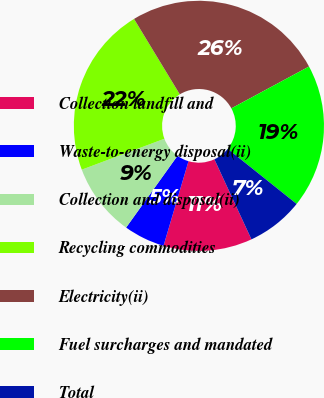<chart> <loc_0><loc_0><loc_500><loc_500><pie_chart><fcel>Collection landfill and<fcel>Waste-to-energy disposal(ii)<fcel>Collection and disposal(ii)<fcel>Recycling commodities<fcel>Electricity(ii)<fcel>Fuel surcharges and mandated<fcel>Total<nl><fcel>11.47%<fcel>5.32%<fcel>9.42%<fcel>22.02%<fcel>25.82%<fcel>18.6%<fcel>7.37%<nl></chart> 